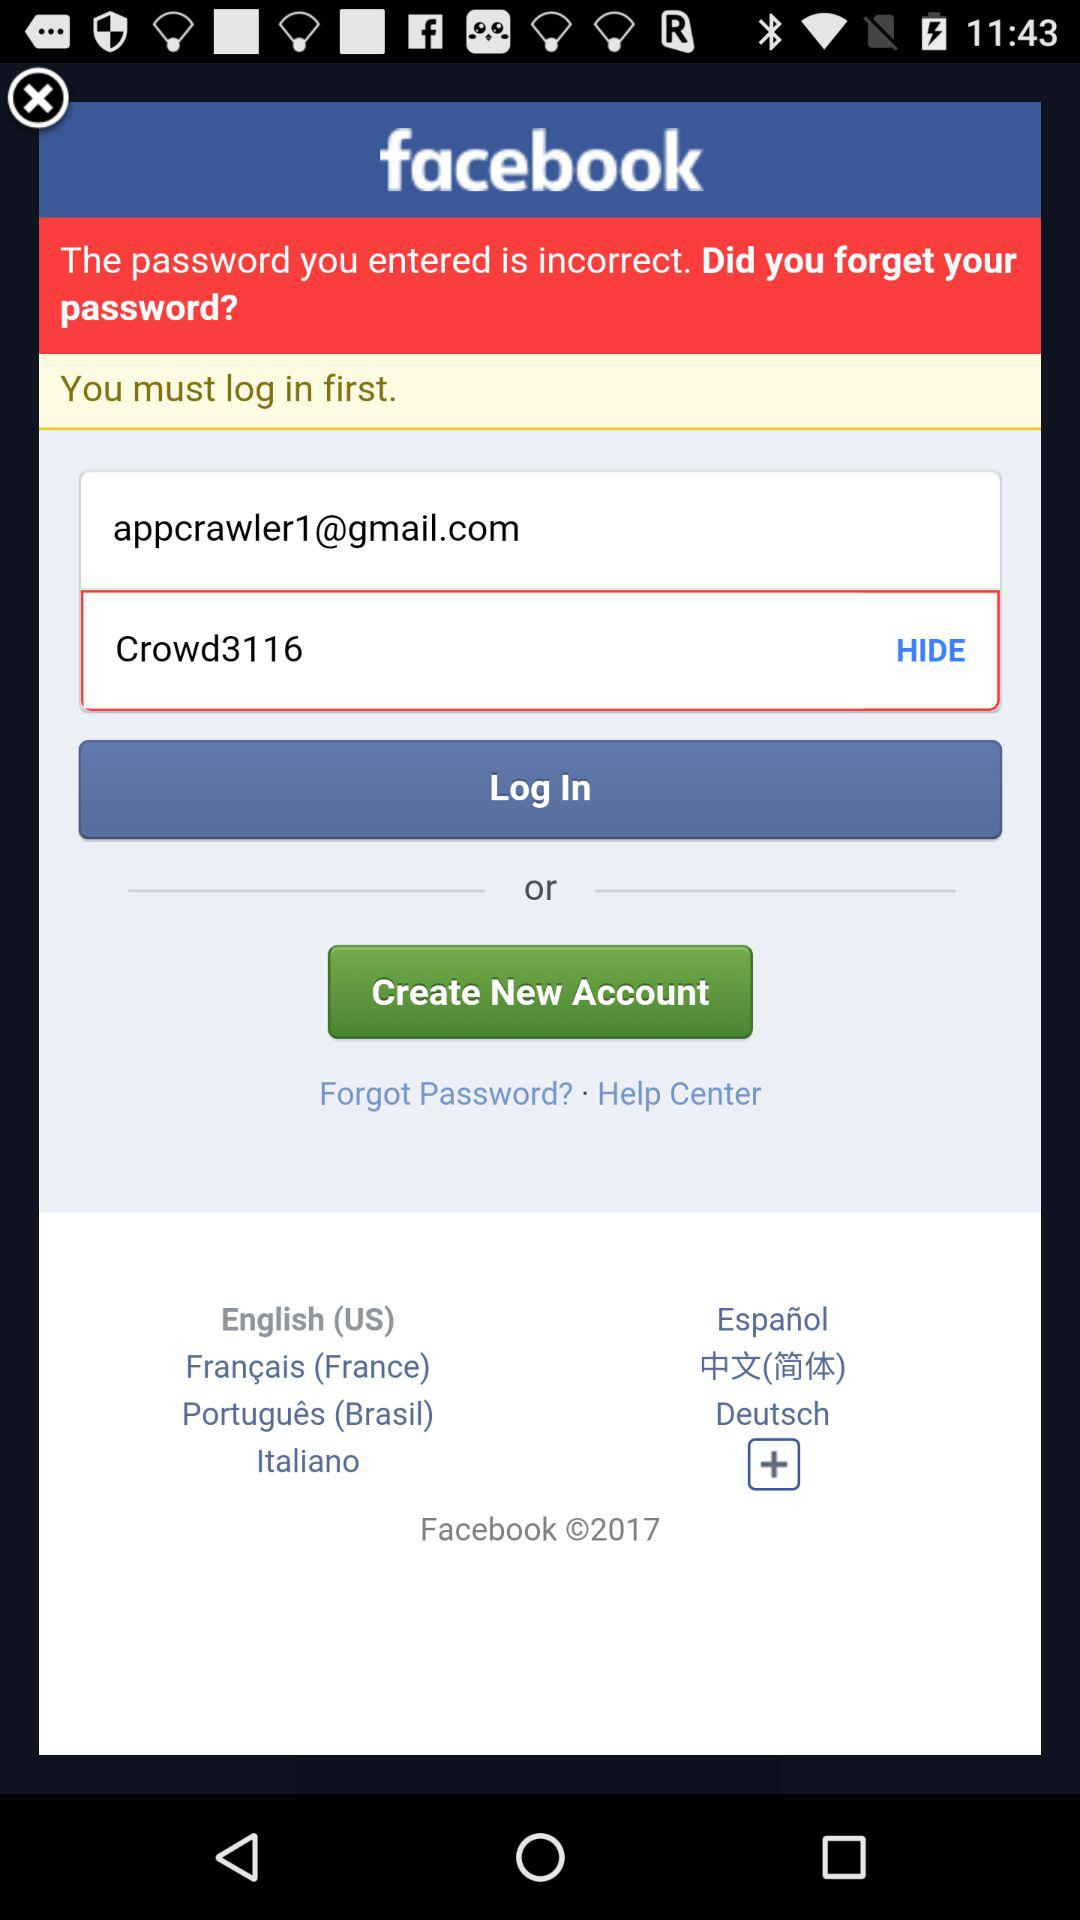What application are we log in to? You are log in to "Facebook". 